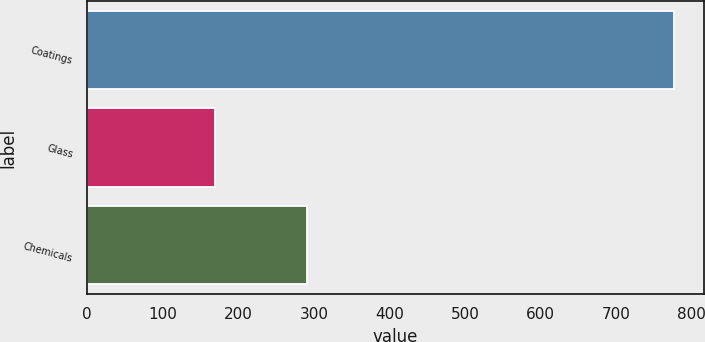<chart> <loc_0><loc_0><loc_500><loc_500><bar_chart><fcel>Coatings<fcel>Glass<fcel>Chemicals<nl><fcel>777<fcel>169<fcel>291<nl></chart> 